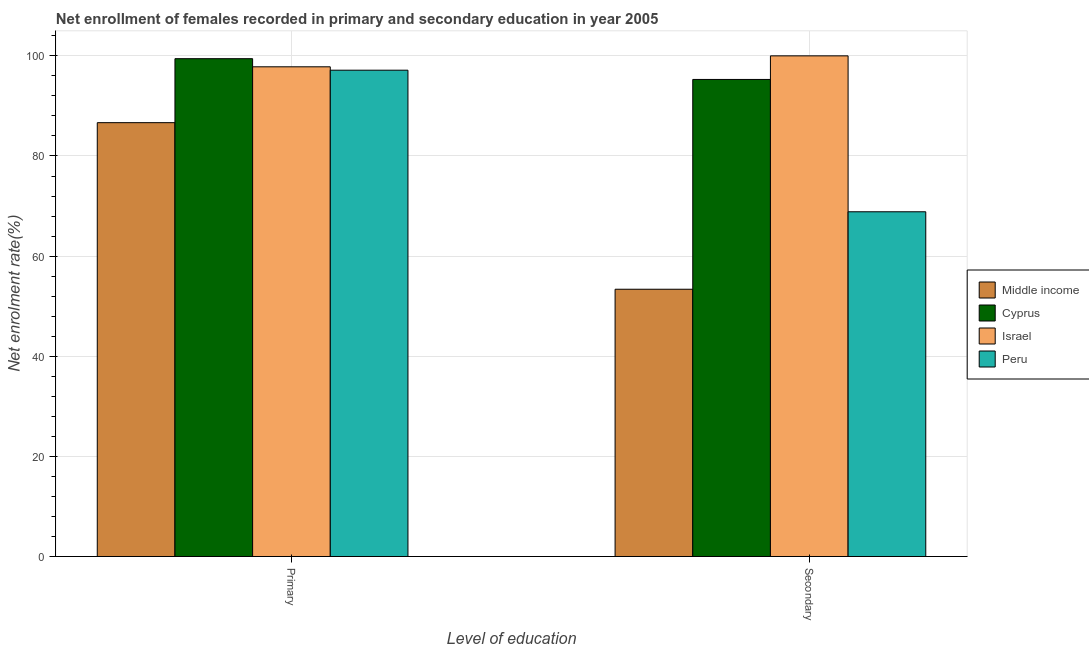How many different coloured bars are there?
Provide a succinct answer. 4. Are the number of bars per tick equal to the number of legend labels?
Make the answer very short. Yes. Are the number of bars on each tick of the X-axis equal?
Give a very brief answer. Yes. How many bars are there on the 1st tick from the left?
Your answer should be compact. 4. How many bars are there on the 1st tick from the right?
Your response must be concise. 4. What is the label of the 1st group of bars from the left?
Make the answer very short. Primary. What is the enrollment rate in primary education in Middle income?
Your answer should be compact. 86.66. Across all countries, what is the maximum enrollment rate in secondary education?
Your answer should be compact. 100. Across all countries, what is the minimum enrollment rate in secondary education?
Offer a terse response. 53.38. In which country was the enrollment rate in secondary education maximum?
Ensure brevity in your answer.  Israel. What is the total enrollment rate in secondary education in the graph?
Provide a succinct answer. 317.53. What is the difference between the enrollment rate in primary education in Middle income and that in Cyprus?
Give a very brief answer. -12.78. What is the difference between the enrollment rate in secondary education in Peru and the enrollment rate in primary education in Middle income?
Ensure brevity in your answer.  -17.8. What is the average enrollment rate in primary education per country?
Provide a short and direct response. 95.26. What is the difference between the enrollment rate in secondary education and enrollment rate in primary education in Cyprus?
Your answer should be compact. -4.15. In how many countries, is the enrollment rate in primary education greater than 96 %?
Make the answer very short. 3. What is the ratio of the enrollment rate in secondary education in Middle income to that in Peru?
Offer a very short reply. 0.78. What does the 3rd bar from the left in Primary represents?
Offer a very short reply. Israel. How many bars are there?
Your answer should be compact. 8. Are the values on the major ticks of Y-axis written in scientific E-notation?
Make the answer very short. No. How many legend labels are there?
Your answer should be very brief. 4. What is the title of the graph?
Give a very brief answer. Net enrollment of females recorded in primary and secondary education in year 2005. Does "Armenia" appear as one of the legend labels in the graph?
Your response must be concise. No. What is the label or title of the X-axis?
Provide a short and direct response. Level of education. What is the label or title of the Y-axis?
Offer a terse response. Net enrolment rate(%). What is the Net enrolment rate(%) in Middle income in Primary?
Offer a very short reply. 86.66. What is the Net enrolment rate(%) of Cyprus in Primary?
Provide a short and direct response. 99.44. What is the Net enrolment rate(%) of Israel in Primary?
Ensure brevity in your answer.  97.81. What is the Net enrolment rate(%) in Peru in Primary?
Your response must be concise. 97.14. What is the Net enrolment rate(%) in Middle income in Secondary?
Your answer should be compact. 53.38. What is the Net enrolment rate(%) in Cyprus in Secondary?
Give a very brief answer. 95.29. What is the Net enrolment rate(%) in Israel in Secondary?
Ensure brevity in your answer.  100. What is the Net enrolment rate(%) in Peru in Secondary?
Provide a succinct answer. 68.86. Across all Level of education, what is the maximum Net enrolment rate(%) in Middle income?
Provide a short and direct response. 86.66. Across all Level of education, what is the maximum Net enrolment rate(%) in Cyprus?
Offer a very short reply. 99.44. Across all Level of education, what is the maximum Net enrolment rate(%) in Israel?
Your response must be concise. 100. Across all Level of education, what is the maximum Net enrolment rate(%) of Peru?
Ensure brevity in your answer.  97.14. Across all Level of education, what is the minimum Net enrolment rate(%) of Middle income?
Your answer should be very brief. 53.38. Across all Level of education, what is the minimum Net enrolment rate(%) in Cyprus?
Keep it short and to the point. 95.29. Across all Level of education, what is the minimum Net enrolment rate(%) in Israel?
Keep it short and to the point. 97.81. Across all Level of education, what is the minimum Net enrolment rate(%) of Peru?
Your response must be concise. 68.86. What is the total Net enrolment rate(%) of Middle income in the graph?
Offer a terse response. 140.04. What is the total Net enrolment rate(%) of Cyprus in the graph?
Provide a short and direct response. 194.72. What is the total Net enrolment rate(%) of Israel in the graph?
Provide a short and direct response. 197.81. What is the total Net enrolment rate(%) of Peru in the graph?
Provide a succinct answer. 165.99. What is the difference between the Net enrolment rate(%) of Middle income in Primary and that in Secondary?
Your response must be concise. 33.27. What is the difference between the Net enrolment rate(%) of Cyprus in Primary and that in Secondary?
Ensure brevity in your answer.  4.15. What is the difference between the Net enrolment rate(%) in Israel in Primary and that in Secondary?
Offer a very short reply. -2.19. What is the difference between the Net enrolment rate(%) of Peru in Primary and that in Secondary?
Your answer should be very brief. 28.28. What is the difference between the Net enrolment rate(%) in Middle income in Primary and the Net enrolment rate(%) in Cyprus in Secondary?
Your answer should be compact. -8.63. What is the difference between the Net enrolment rate(%) of Middle income in Primary and the Net enrolment rate(%) of Israel in Secondary?
Make the answer very short. -13.34. What is the difference between the Net enrolment rate(%) of Middle income in Primary and the Net enrolment rate(%) of Peru in Secondary?
Keep it short and to the point. 17.8. What is the difference between the Net enrolment rate(%) in Cyprus in Primary and the Net enrolment rate(%) in Israel in Secondary?
Make the answer very short. -0.56. What is the difference between the Net enrolment rate(%) in Cyprus in Primary and the Net enrolment rate(%) in Peru in Secondary?
Your answer should be compact. 30.58. What is the difference between the Net enrolment rate(%) of Israel in Primary and the Net enrolment rate(%) of Peru in Secondary?
Offer a very short reply. 28.96. What is the average Net enrolment rate(%) of Middle income per Level of education?
Your answer should be compact. 70.02. What is the average Net enrolment rate(%) in Cyprus per Level of education?
Keep it short and to the point. 97.36. What is the average Net enrolment rate(%) in Israel per Level of education?
Your answer should be compact. 98.91. What is the average Net enrolment rate(%) of Peru per Level of education?
Give a very brief answer. 83. What is the difference between the Net enrolment rate(%) of Middle income and Net enrolment rate(%) of Cyprus in Primary?
Provide a succinct answer. -12.78. What is the difference between the Net enrolment rate(%) of Middle income and Net enrolment rate(%) of Israel in Primary?
Provide a succinct answer. -11.16. What is the difference between the Net enrolment rate(%) of Middle income and Net enrolment rate(%) of Peru in Primary?
Your answer should be very brief. -10.48. What is the difference between the Net enrolment rate(%) of Cyprus and Net enrolment rate(%) of Israel in Primary?
Offer a very short reply. 1.62. What is the difference between the Net enrolment rate(%) of Cyprus and Net enrolment rate(%) of Peru in Primary?
Your answer should be compact. 2.3. What is the difference between the Net enrolment rate(%) in Israel and Net enrolment rate(%) in Peru in Primary?
Your answer should be compact. 0.68. What is the difference between the Net enrolment rate(%) of Middle income and Net enrolment rate(%) of Cyprus in Secondary?
Give a very brief answer. -41.9. What is the difference between the Net enrolment rate(%) of Middle income and Net enrolment rate(%) of Israel in Secondary?
Offer a very short reply. -46.62. What is the difference between the Net enrolment rate(%) in Middle income and Net enrolment rate(%) in Peru in Secondary?
Your answer should be compact. -15.47. What is the difference between the Net enrolment rate(%) of Cyprus and Net enrolment rate(%) of Israel in Secondary?
Provide a succinct answer. -4.71. What is the difference between the Net enrolment rate(%) in Cyprus and Net enrolment rate(%) in Peru in Secondary?
Your response must be concise. 26.43. What is the difference between the Net enrolment rate(%) in Israel and Net enrolment rate(%) in Peru in Secondary?
Offer a terse response. 31.14. What is the ratio of the Net enrolment rate(%) in Middle income in Primary to that in Secondary?
Give a very brief answer. 1.62. What is the ratio of the Net enrolment rate(%) of Cyprus in Primary to that in Secondary?
Provide a succinct answer. 1.04. What is the ratio of the Net enrolment rate(%) in Israel in Primary to that in Secondary?
Make the answer very short. 0.98. What is the ratio of the Net enrolment rate(%) in Peru in Primary to that in Secondary?
Your response must be concise. 1.41. What is the difference between the highest and the second highest Net enrolment rate(%) in Middle income?
Your response must be concise. 33.27. What is the difference between the highest and the second highest Net enrolment rate(%) of Cyprus?
Make the answer very short. 4.15. What is the difference between the highest and the second highest Net enrolment rate(%) of Israel?
Give a very brief answer. 2.19. What is the difference between the highest and the second highest Net enrolment rate(%) in Peru?
Provide a succinct answer. 28.28. What is the difference between the highest and the lowest Net enrolment rate(%) in Middle income?
Provide a succinct answer. 33.27. What is the difference between the highest and the lowest Net enrolment rate(%) in Cyprus?
Your answer should be very brief. 4.15. What is the difference between the highest and the lowest Net enrolment rate(%) in Israel?
Keep it short and to the point. 2.19. What is the difference between the highest and the lowest Net enrolment rate(%) of Peru?
Ensure brevity in your answer.  28.28. 